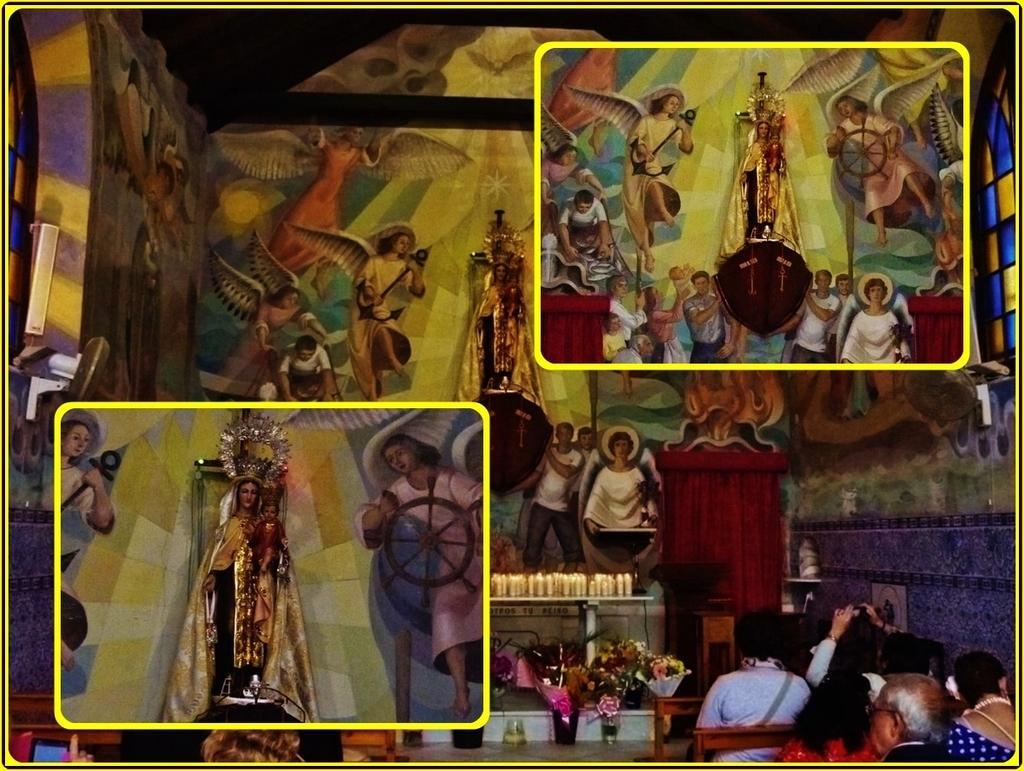How would you summarize this image in a sentence or two? In the image we can see the image is a collage of three pictures and in a image there is a statue of a person holding baby in her hand. There are people sitting on the bench and there are candles kept on the table. 